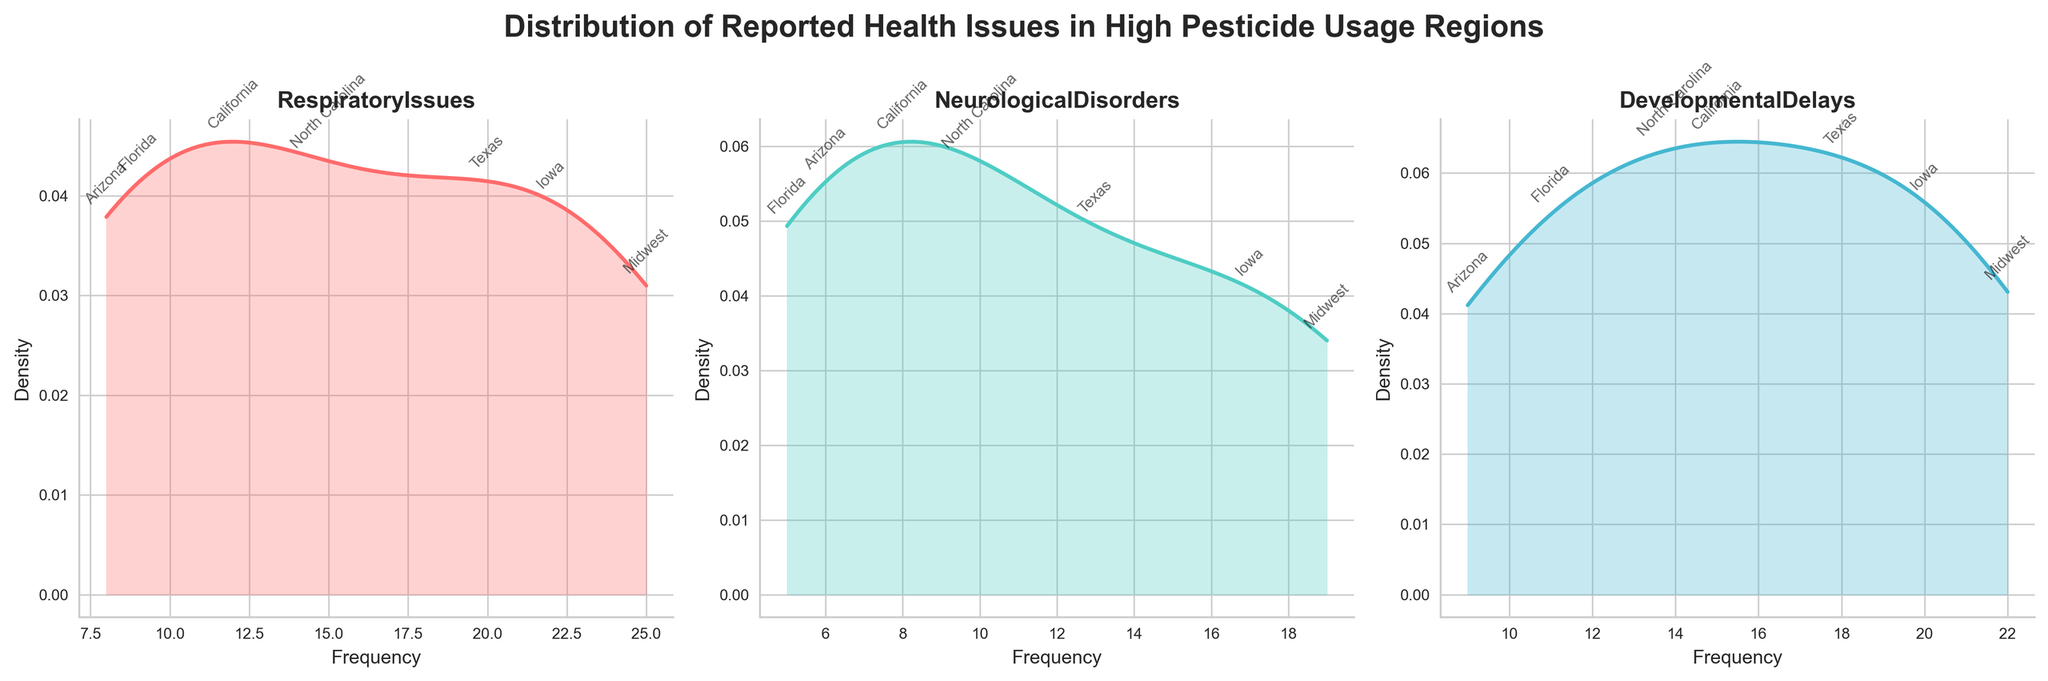What is the title of the figure? The title is usually located at the top of the figure. Reading it gives the overall topic which in this case is about health issues in children.
Answer: Distribution of Reported Health Issues in High Pesticide Usage Regions Which health issue among children has the highest density peak in Midwest? By looking at the x-axis (Frequency) and the y-axis (Density), identify the health issue with the peak that is highest on the y-axis in the Midwest region.
Answer: Respiratory Issues How many regions are labeled within the 'Neurological Disorders' subplot? By counting the distinct labels or annotations within the 'NeurologicalDisorders' subplot, you can determine how many regions have been highlighted.
Answer: 6 Which region has the lowest frequency of respiratory issues reported? Within the 'RespiratoryIssues' subplot, identify the region with the lowest x-axis value from the annotations.
Answer: Arizona Compare the highest densities for 'Developmental Delays' and 'Respiratory Issues'. Which is higher? Compare the y-values of the highest peaks in the 'Developmental Delays' subplot and 'Respiratory Issues' subplot to determine which health issue has a higher density.
Answer: Respiratory Issues What is the frequency range for 'Developmental Delays'? Check the x-axis values for the minimum and maximum frequencies in the 'Developmental Delays' subplot.
Answer: 9 to 22 Between Iowa and Texas, which region has more reported cases of neurological disorders? Look at the annotations in the 'NeurologicalDisorders' subplot and compare the frequencies labeled for Iowa and Texas.
Answer: Iowa Do 'Neurological Disorders' or 'Respiratory Issues' have a broader spread of frequencies? Compare the range of x-axis values (frequencies) for both 'NeurologicalDisorders' and 'RespiratoryIssues' subplots to see which one has a wider spread.
Answer: Respiratory Issues Which region shows the highest frequency for 'Developmental Delays'? Identify the annotation with the highest x-axis value within the 'DevelopmentalDelays' subplot.
Answer: Midwest Are there any regions with overlapping frequencies for 'Respiratory Issues' and 'Developmental Delays'? Compare the frequencies annotated in the subplots for 'RespiratoryIssues' and 'DevelopmentalDelays' to see if any regions share the same values.
Answer: Yes, Texas and Iowa both appear in both subplots 